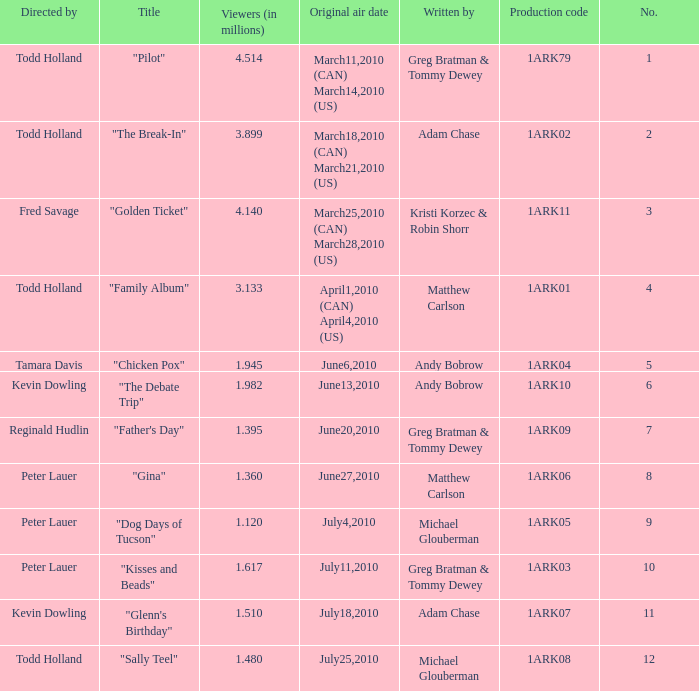List all who wrote for production code 1ark07. Adam Chase. 